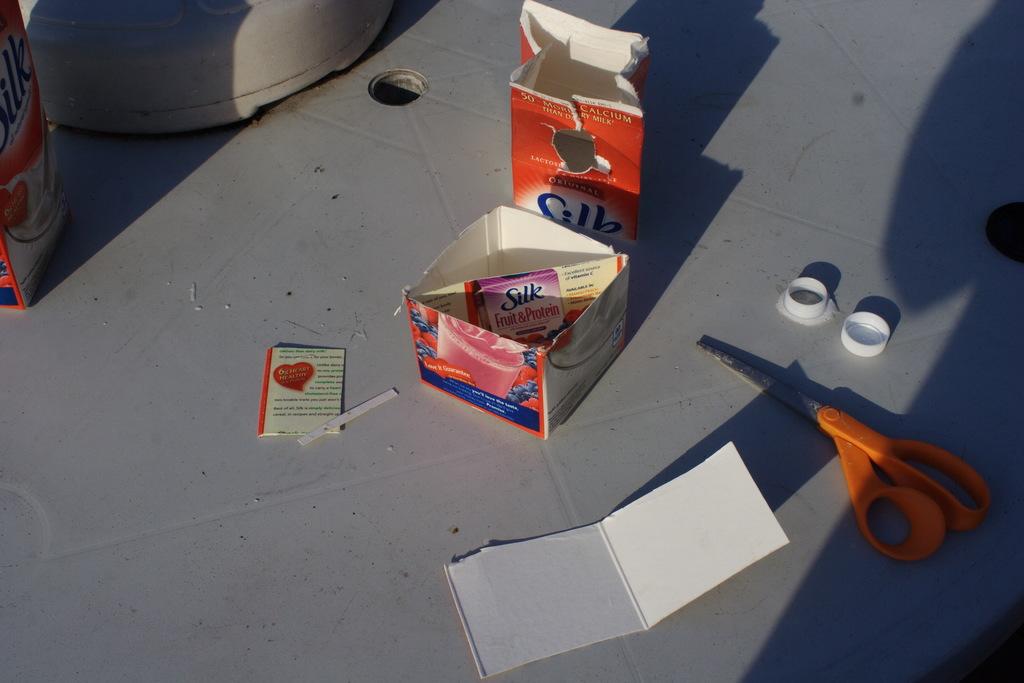What is the brand of this carton?
Ensure brevity in your answer.  Silk. What do the biggest letters say?
Make the answer very short. Silk. 